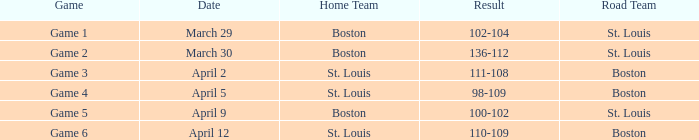I'm looking to parse the entire table for insights. Could you assist me with that? {'header': ['Game', 'Date', 'Home Team', 'Result', 'Road Team'], 'rows': [['Game 1', 'March 29', 'Boston', '102-104', 'St. Louis'], ['Game 2', 'March 30', 'Boston', '136-112', 'St. Louis'], ['Game 3', 'April 2', 'St. Louis', '111-108', 'Boston'], ['Game 4', 'April 5', 'St. Louis', '98-109', 'Boston'], ['Game 5', 'April 9', 'Boston', '100-102', 'St. Louis'], ['Game 6', 'April 12', 'St. Louis', '110-109', 'Boston']]} What is the Result of Game 3? 111-108. 